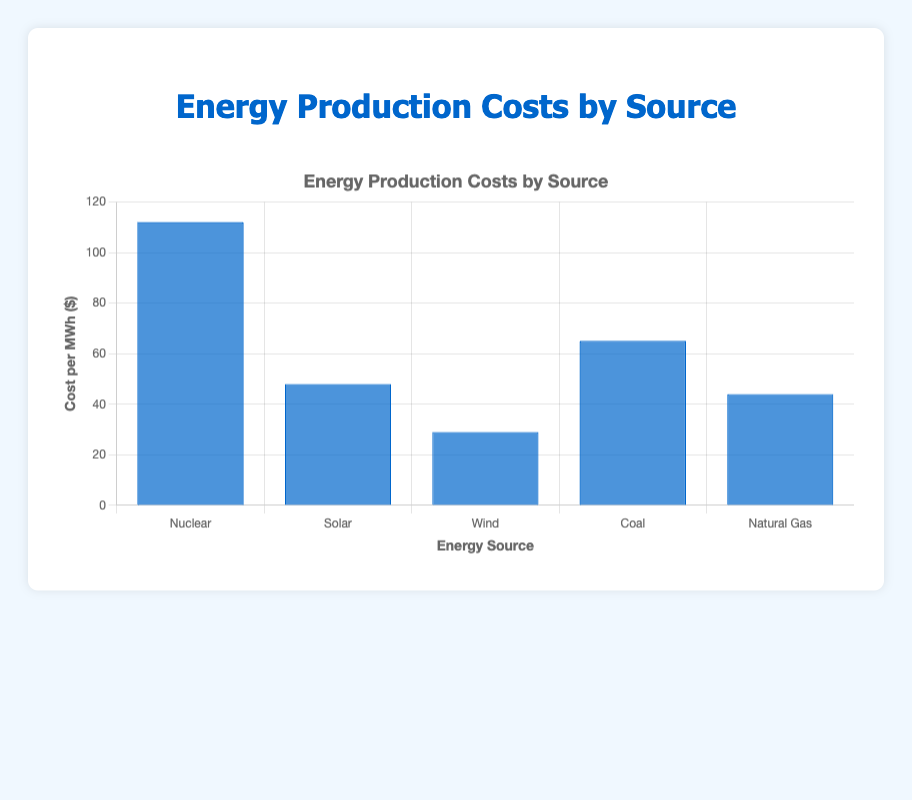Which energy source has the lowest production cost per MWh? By looking at the height of the bars, we can see that Wind has the shortest bar, indicating it has the lowest cost per MWh.
Answer: Wind How much more expensive is Nuclear compared to Solar per MWh? To find the difference in cost per MWh between Nuclear and Solar, we subtract Solar's cost from Nuclear's cost: 112 - 48 = 64.
Answer: 64 What is the average production cost per MWh among all the energy sources? First, sum all the costs: 112 (Nuclear) + 48 (Solar) + 29 (Wind) + 65 (Coal) + 44 (Natural Gas) = 298. Then, divide by the number of sources: 298 / 5 = 59.6.
Answer: 59.6 Which two energy sources have the smallest difference in production cost per MWh? By comparing the differences between each pair of costs, we find that Solar (48) and Natural Gas (44) have the smallest difference: 48 - 44 = 4.
Answer: Solar and Natural Gas If we combine the costs of Solar and Wind, how do they compare to the cost of Nuclear? The combined cost of Solar and Wind is 48 + 29 = 77. Comparing this to Nuclear’s cost, 77 is less than 112.
Answer: Less than Arrange the energy sources in decreasing order of their production costs. By comparing the height of the bars, we can list them as follows: Nuclear (112), Coal (65), Solar (48), Natural Gas (44), Wind (29).
Answer: Nuclear, Coal, Solar, Natural Gas, Wind How much more does it cost to produce energy from Coal compared to Natural Gas? To find the difference in cost per MWh between Coal and Natural Gas, we subtract Natural Gas's cost from Coal's cost: 65 - 44 = 21.
Answer: 21 What is the total combined production cost of Natural Gas and Coal per MWh? Sum the two costs: 44 (Natural Gas) + 65 (Coal) = 109.
Answer: 109 Which energy source has a production cost closest to the average production cost per MWh? The average cost per MWh is 59.6. Among the energy sources, Coal's cost (65) is closest to this average.
Answer: Coal 